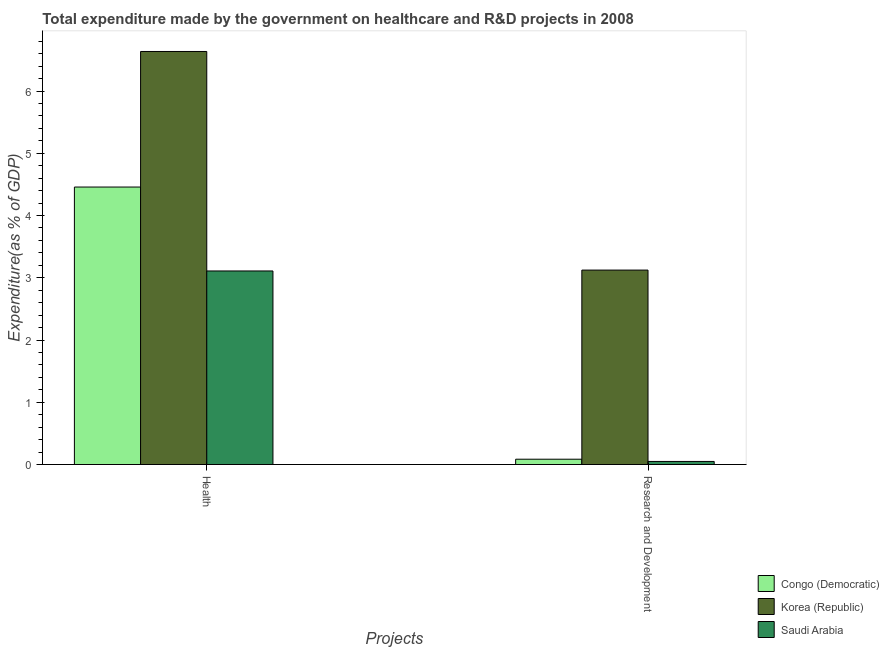How many groups of bars are there?
Offer a terse response. 2. Are the number of bars per tick equal to the number of legend labels?
Your answer should be very brief. Yes. How many bars are there on the 1st tick from the left?
Your answer should be very brief. 3. How many bars are there on the 2nd tick from the right?
Your response must be concise. 3. What is the label of the 2nd group of bars from the left?
Your response must be concise. Research and Development. What is the expenditure in r&d in Korea (Republic)?
Your response must be concise. 3.12. Across all countries, what is the maximum expenditure in healthcare?
Your answer should be compact. 6.64. Across all countries, what is the minimum expenditure in r&d?
Provide a succinct answer. 0.05. In which country was the expenditure in r&d maximum?
Make the answer very short. Korea (Republic). In which country was the expenditure in r&d minimum?
Your answer should be very brief. Saudi Arabia. What is the total expenditure in r&d in the graph?
Provide a succinct answer. 3.26. What is the difference between the expenditure in healthcare in Saudi Arabia and that in Korea (Republic)?
Your response must be concise. -3.53. What is the difference between the expenditure in healthcare in Korea (Republic) and the expenditure in r&d in Saudi Arabia?
Offer a very short reply. 6.59. What is the average expenditure in healthcare per country?
Your answer should be very brief. 4.73. What is the difference between the expenditure in healthcare and expenditure in r&d in Saudi Arabia?
Provide a succinct answer. 3.06. What is the ratio of the expenditure in r&d in Congo (Democratic) to that in Saudi Arabia?
Offer a very short reply. 1.73. How many bars are there?
Offer a terse response. 6. Are all the bars in the graph horizontal?
Your response must be concise. No. How many countries are there in the graph?
Your answer should be compact. 3. Does the graph contain grids?
Offer a terse response. No. How many legend labels are there?
Your answer should be very brief. 3. What is the title of the graph?
Offer a terse response. Total expenditure made by the government on healthcare and R&D projects in 2008. Does "Hong Kong" appear as one of the legend labels in the graph?
Offer a very short reply. No. What is the label or title of the X-axis?
Your answer should be compact. Projects. What is the label or title of the Y-axis?
Keep it short and to the point. Expenditure(as % of GDP). What is the Expenditure(as % of GDP) of Congo (Democratic) in Health?
Your answer should be very brief. 4.46. What is the Expenditure(as % of GDP) of Korea (Republic) in Health?
Your response must be concise. 6.64. What is the Expenditure(as % of GDP) in Saudi Arabia in Health?
Your response must be concise. 3.11. What is the Expenditure(as % of GDP) of Congo (Democratic) in Research and Development?
Provide a succinct answer. 0.09. What is the Expenditure(as % of GDP) in Korea (Republic) in Research and Development?
Provide a succinct answer. 3.12. What is the Expenditure(as % of GDP) of Saudi Arabia in Research and Development?
Your answer should be very brief. 0.05. Across all Projects, what is the maximum Expenditure(as % of GDP) in Congo (Democratic)?
Your answer should be compact. 4.46. Across all Projects, what is the maximum Expenditure(as % of GDP) in Korea (Republic)?
Your answer should be very brief. 6.64. Across all Projects, what is the maximum Expenditure(as % of GDP) in Saudi Arabia?
Keep it short and to the point. 3.11. Across all Projects, what is the minimum Expenditure(as % of GDP) of Congo (Democratic)?
Offer a very short reply. 0.09. Across all Projects, what is the minimum Expenditure(as % of GDP) in Korea (Republic)?
Give a very brief answer. 3.12. Across all Projects, what is the minimum Expenditure(as % of GDP) in Saudi Arabia?
Offer a very short reply. 0.05. What is the total Expenditure(as % of GDP) in Congo (Democratic) in the graph?
Provide a succinct answer. 4.54. What is the total Expenditure(as % of GDP) in Korea (Republic) in the graph?
Your answer should be very brief. 9.76. What is the total Expenditure(as % of GDP) in Saudi Arabia in the graph?
Make the answer very short. 3.16. What is the difference between the Expenditure(as % of GDP) in Congo (Democratic) in Health and that in Research and Development?
Your answer should be compact. 4.37. What is the difference between the Expenditure(as % of GDP) in Korea (Republic) in Health and that in Research and Development?
Offer a very short reply. 3.51. What is the difference between the Expenditure(as % of GDP) in Saudi Arabia in Health and that in Research and Development?
Ensure brevity in your answer.  3.06. What is the difference between the Expenditure(as % of GDP) of Congo (Democratic) in Health and the Expenditure(as % of GDP) of Korea (Republic) in Research and Development?
Ensure brevity in your answer.  1.33. What is the difference between the Expenditure(as % of GDP) in Congo (Democratic) in Health and the Expenditure(as % of GDP) in Saudi Arabia in Research and Development?
Your response must be concise. 4.41. What is the difference between the Expenditure(as % of GDP) in Korea (Republic) in Health and the Expenditure(as % of GDP) in Saudi Arabia in Research and Development?
Give a very brief answer. 6.59. What is the average Expenditure(as % of GDP) of Congo (Democratic) per Projects?
Your response must be concise. 2.27. What is the average Expenditure(as % of GDP) in Korea (Republic) per Projects?
Your answer should be very brief. 4.88. What is the average Expenditure(as % of GDP) of Saudi Arabia per Projects?
Ensure brevity in your answer.  1.58. What is the difference between the Expenditure(as % of GDP) of Congo (Democratic) and Expenditure(as % of GDP) of Korea (Republic) in Health?
Provide a succinct answer. -2.18. What is the difference between the Expenditure(as % of GDP) in Congo (Democratic) and Expenditure(as % of GDP) in Saudi Arabia in Health?
Keep it short and to the point. 1.35. What is the difference between the Expenditure(as % of GDP) of Korea (Republic) and Expenditure(as % of GDP) of Saudi Arabia in Health?
Provide a succinct answer. 3.53. What is the difference between the Expenditure(as % of GDP) in Congo (Democratic) and Expenditure(as % of GDP) in Korea (Republic) in Research and Development?
Make the answer very short. -3.04. What is the difference between the Expenditure(as % of GDP) of Congo (Democratic) and Expenditure(as % of GDP) of Saudi Arabia in Research and Development?
Provide a succinct answer. 0.04. What is the difference between the Expenditure(as % of GDP) of Korea (Republic) and Expenditure(as % of GDP) of Saudi Arabia in Research and Development?
Give a very brief answer. 3.07. What is the ratio of the Expenditure(as % of GDP) of Congo (Democratic) in Health to that in Research and Development?
Offer a very short reply. 52.43. What is the ratio of the Expenditure(as % of GDP) in Korea (Republic) in Health to that in Research and Development?
Ensure brevity in your answer.  2.12. What is the ratio of the Expenditure(as % of GDP) in Saudi Arabia in Health to that in Research and Development?
Offer a terse response. 63.43. What is the difference between the highest and the second highest Expenditure(as % of GDP) of Congo (Democratic)?
Your answer should be very brief. 4.37. What is the difference between the highest and the second highest Expenditure(as % of GDP) in Korea (Republic)?
Your answer should be compact. 3.51. What is the difference between the highest and the second highest Expenditure(as % of GDP) in Saudi Arabia?
Give a very brief answer. 3.06. What is the difference between the highest and the lowest Expenditure(as % of GDP) of Congo (Democratic)?
Keep it short and to the point. 4.37. What is the difference between the highest and the lowest Expenditure(as % of GDP) in Korea (Republic)?
Your response must be concise. 3.51. What is the difference between the highest and the lowest Expenditure(as % of GDP) of Saudi Arabia?
Keep it short and to the point. 3.06. 